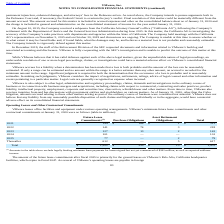According to Vmware's financial document, What does the amount for future lease commitments exclude? legally binding minimum lease payments for leases signed but not yet commenced of $361 million, as well as expected sublease income.. The document states: "(1) Amounts in the table above exclude legally binding minimum lease payments for leases signed but not yet commenced of $361 million, as well as expe..." Also, What were the purchase obligations in 2022? According to the financial document, 74 (in millions). The relevant text states: "2022 141 74 3 218..." Also, What were the Asset Retirement Obligations in 2023? According to the financial document, 2 (in millions). The relevant text states: "n the consolidated balance sheet as of January 31, 2020 and the charge is included in general and administrative on the consolidated statement of income..." Also, can you calculate: What was the change in future lease commitments between 2021 and 2022? Based on the calculation: 141-144, the result is -3 (in millions). This is based on the information: "2021 $ 144 $ 168 $ 1 $ 313 2022 141 74 3 218..." The key data points involved are: 141, 144. Also, can you calculate: What was the change in total contractual obligations between 2023 and 2022? Based on the calculation: 142-218, the result is -76 (in millions). This is based on the information: "2023 127 13 2 142 2022 141 74 3 218..." The key data points involved are: 142, 218. Also, can you calculate: What was the percentage change in purchase obligations between 2022 and 2023? To answer this question, I need to perform calculations using the financial data. The calculation is: (13-74)/74, which equals -82.43 (percentage). This is based on the information: "2022 141 74 3 218 2023 127 13 2 142..." The key data points involved are: 13, 74. 